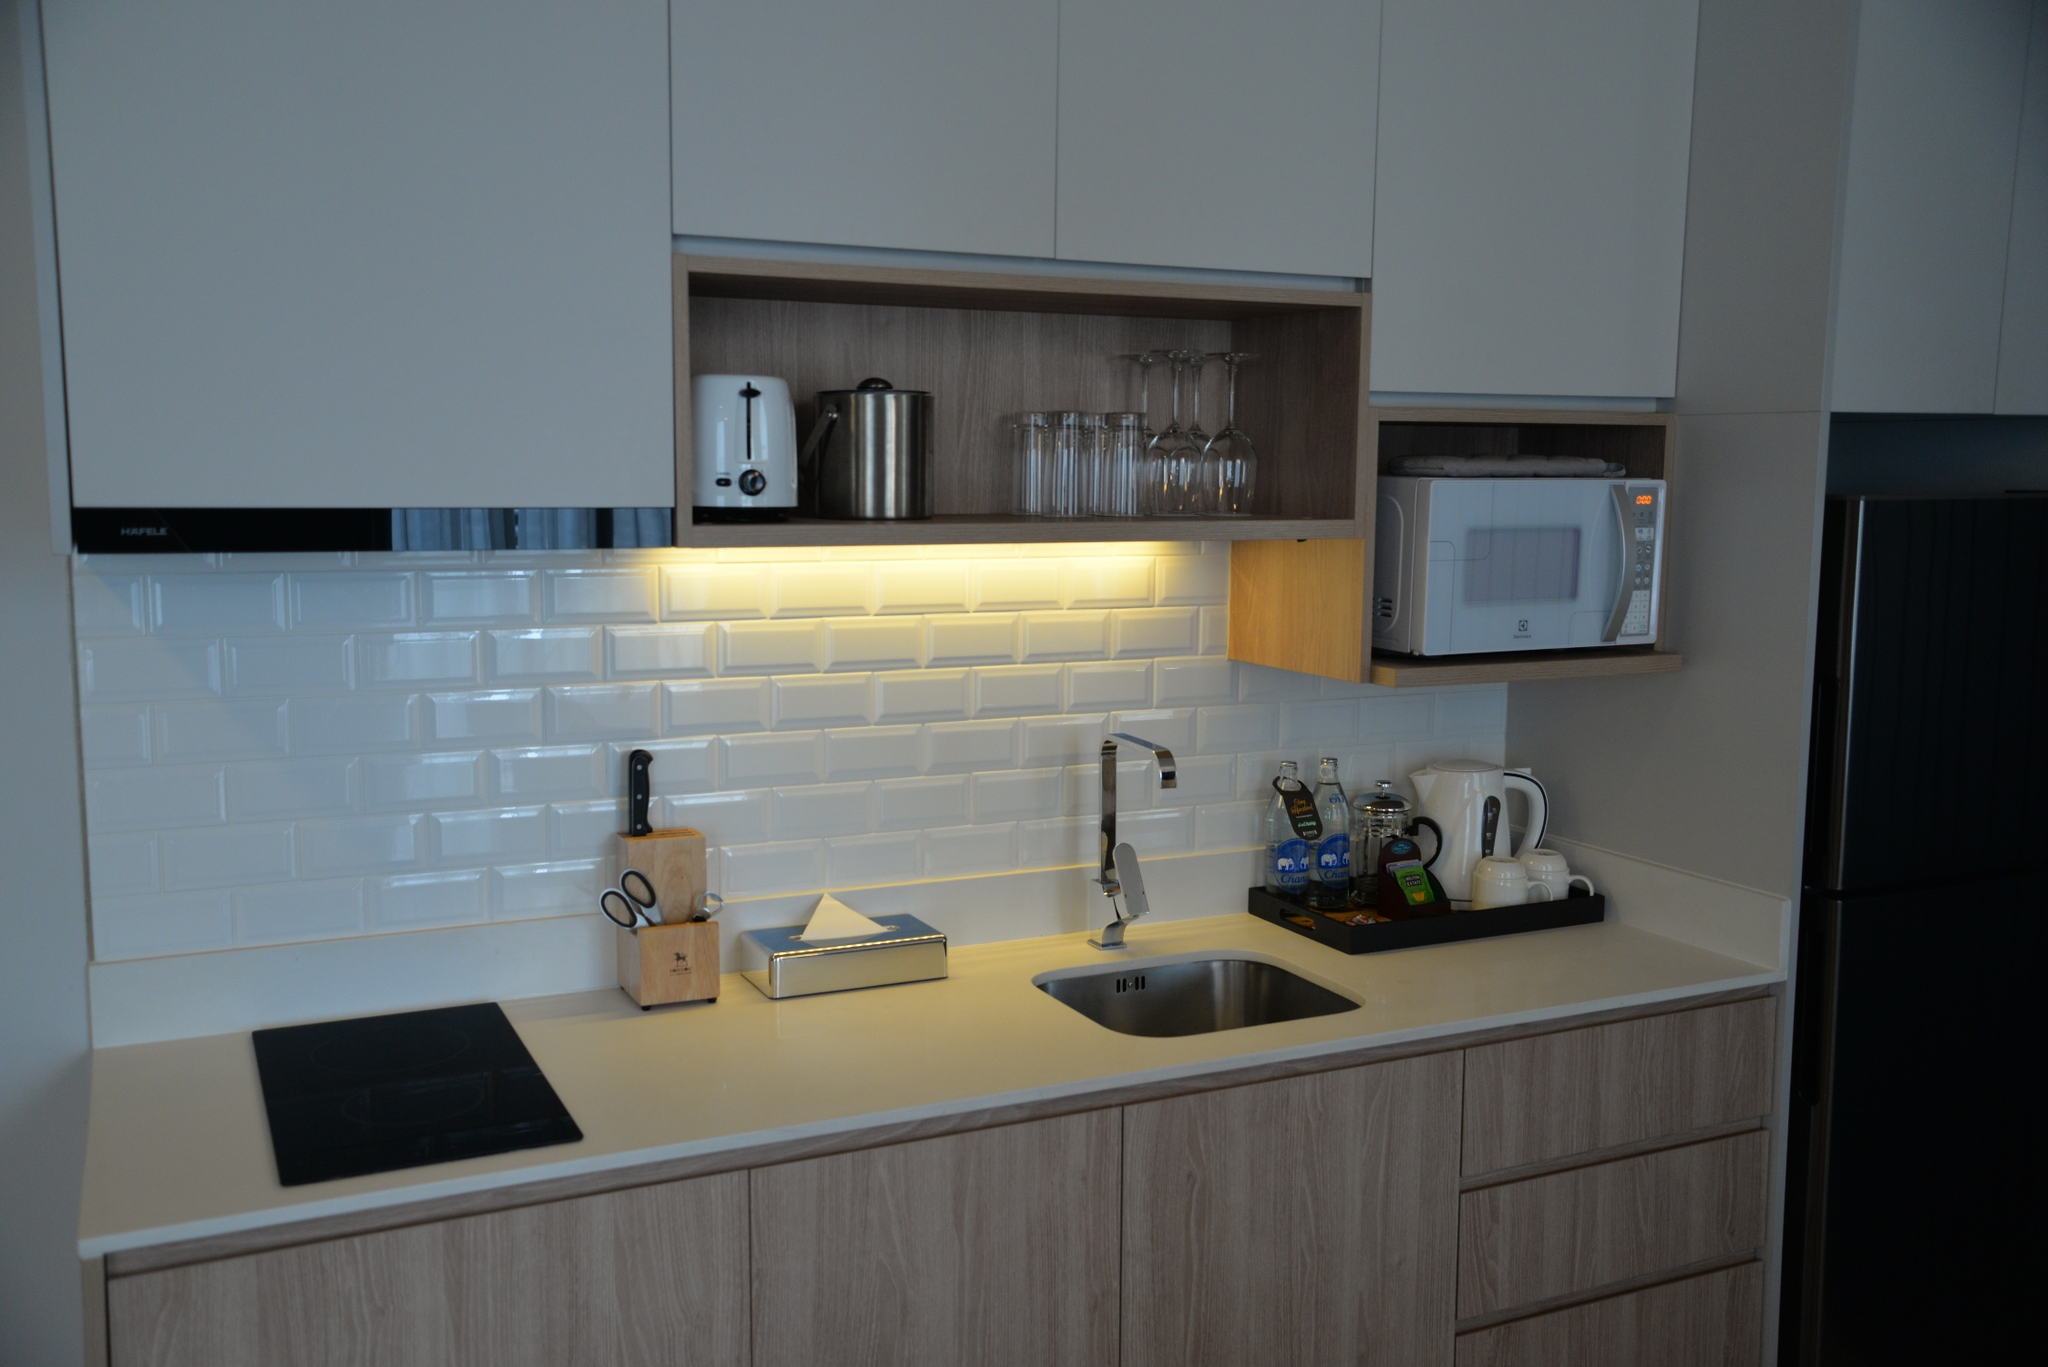Can you describe the functionality and design elements of this kitchen in detail? This kitchen combines functionality with a modern aesthetic. The sleek, light-gray countertop provides ample workspace and hosts a black induction cooktop, ideal for efficient and quick cooking, and a stylish stainless steel sink. Above the sink, a large window allows natural light to flood in, enhancing the bright and airy ambiance of the room. The backsplash features glossy white subway tiles adding a sophisticated touch and making cleaning effortless. The wooden cabinetry offers generous storage, with some sections having glass doors to showcase elegant glassware. On the countertop, small appliances such as a coffee maker, kettle, and toaster are neatly arranged, ensuring that everyday essentials are within easy reach. Integrated appliances include a seamlessly blended microwave and a refrigerator on the right, preserving the kitchen’s sleek lines. Thoughtful lighting under the cabinets brightens the workspace, making it both practical and welcoming for any culinary activity. 